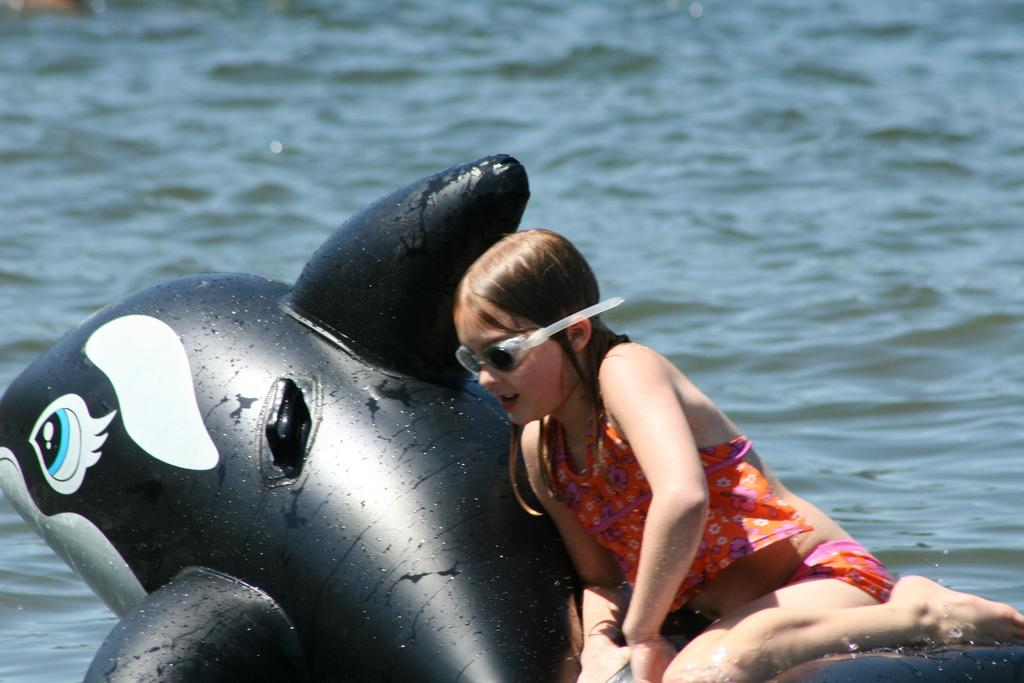What is the main subject of the image? There is a person in the image. What is the person doing in the image? The person is sitting on a balloon. Where is the balloon located in the image? The balloon is on the water. What invention does the person regret in the image? There is no indication in the image that the person regrets any invention. 